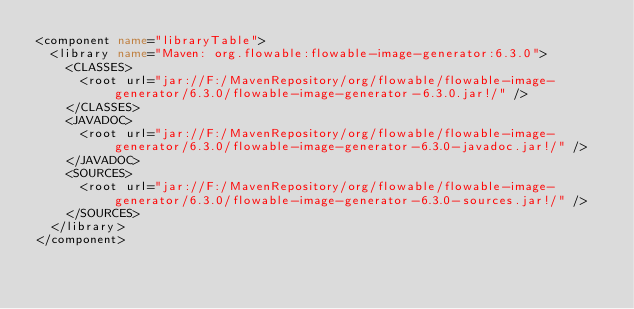Convert code to text. <code><loc_0><loc_0><loc_500><loc_500><_XML_><component name="libraryTable">
  <library name="Maven: org.flowable:flowable-image-generator:6.3.0">
    <CLASSES>
      <root url="jar://F:/MavenRepository/org/flowable/flowable-image-generator/6.3.0/flowable-image-generator-6.3.0.jar!/" />
    </CLASSES>
    <JAVADOC>
      <root url="jar://F:/MavenRepository/org/flowable/flowable-image-generator/6.3.0/flowable-image-generator-6.3.0-javadoc.jar!/" />
    </JAVADOC>
    <SOURCES>
      <root url="jar://F:/MavenRepository/org/flowable/flowable-image-generator/6.3.0/flowable-image-generator-6.3.0-sources.jar!/" />
    </SOURCES>
  </library>
</component></code> 